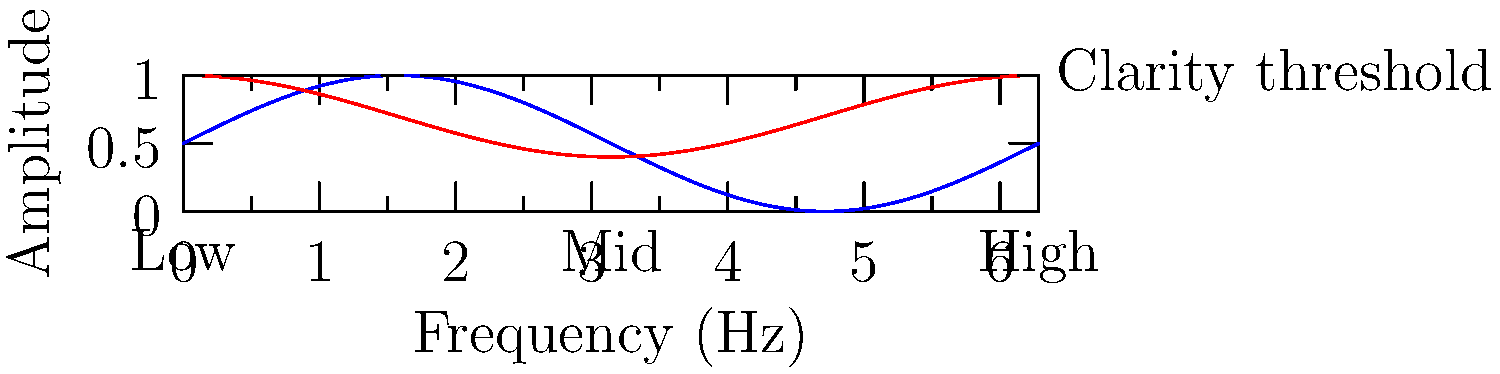In the diagram, which frequency range requires the most significant EQ boost to enhance voice clarity? To determine which frequency range requires the most significant EQ boost for voice clarity, we need to analyze the relationship between the voice frequency spectrum (blue line) and the EQ adjustments (red line):

1. The x-axis represents the frequency range from low to high.
2. The y-axis represents the amplitude or intensity of the sound.
3. The blue line shows the natural voice frequency spectrum.
4. The red line indicates the EQ adjustments made to enhance clarity.
5. The dashed line represents the clarity threshold.

Step-by-step analysis:
1. Low frequencies (left side of the graph):
   - The voice spectrum is relatively high.
   - The EQ adjustment is below the voice spectrum.
   - This suggests a reduction in low frequencies.

2. Mid frequencies (middle of the graph):
   - The voice spectrum dips below the clarity threshold.
   - The EQ adjustment rises above the voice spectrum.
   - This indicates a boost in mid frequencies to enhance clarity.

3. High frequencies (right side of the graph):
   - The voice spectrum rises again.
   - The EQ adjustment closely follows the voice spectrum.
   - This suggests minimal adjustment in high frequencies.

Comparing these three ranges, we can see that the mid-frequency range shows the largest gap between the voice spectrum and the EQ adjustment line, with the EQ line rising significantly above the voice spectrum.
Answer: Mid-frequency range 